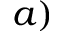<formula> <loc_0><loc_0><loc_500><loc_500>a )</formula> 